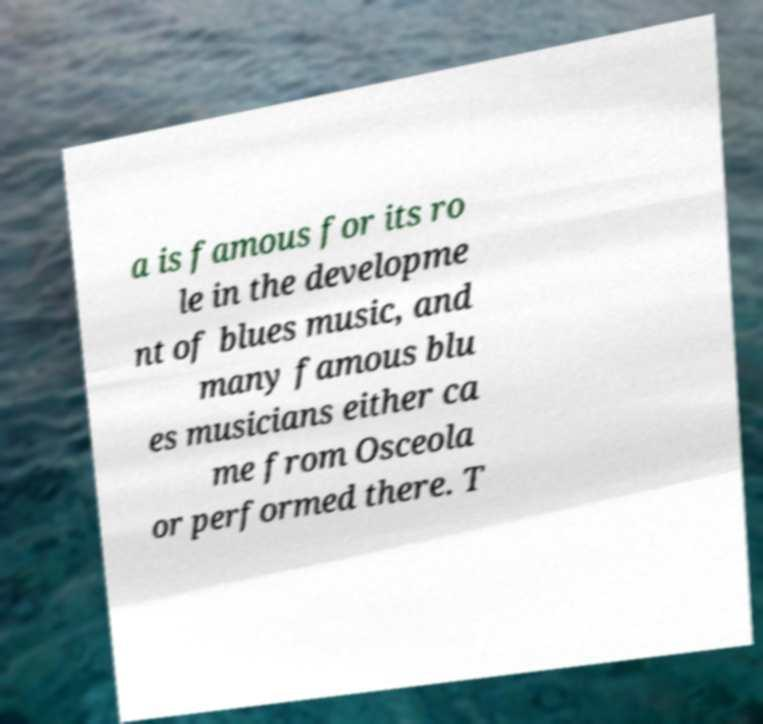Can you read and provide the text displayed in the image?This photo seems to have some interesting text. Can you extract and type it out for me? a is famous for its ro le in the developme nt of blues music, and many famous blu es musicians either ca me from Osceola or performed there. T 